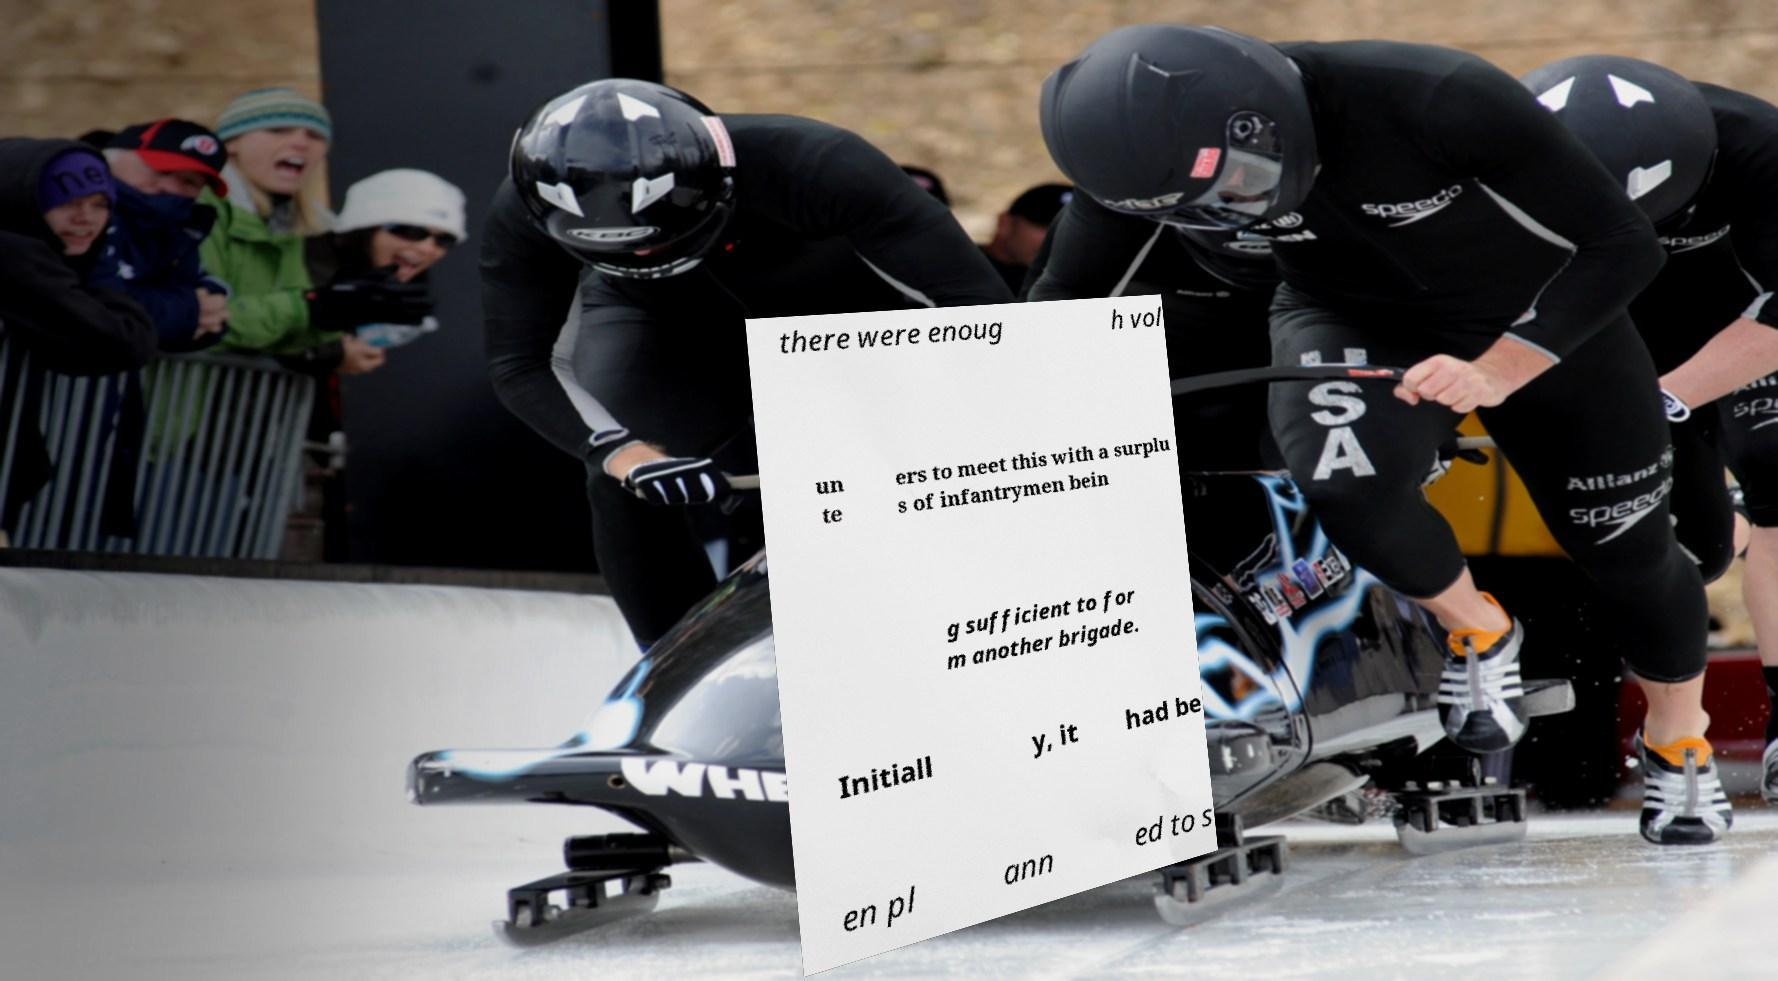Could you extract and type out the text from this image? there were enoug h vol un te ers to meet this with a surplu s of infantrymen bein g sufficient to for m another brigade. Initiall y, it had be en pl ann ed to s 